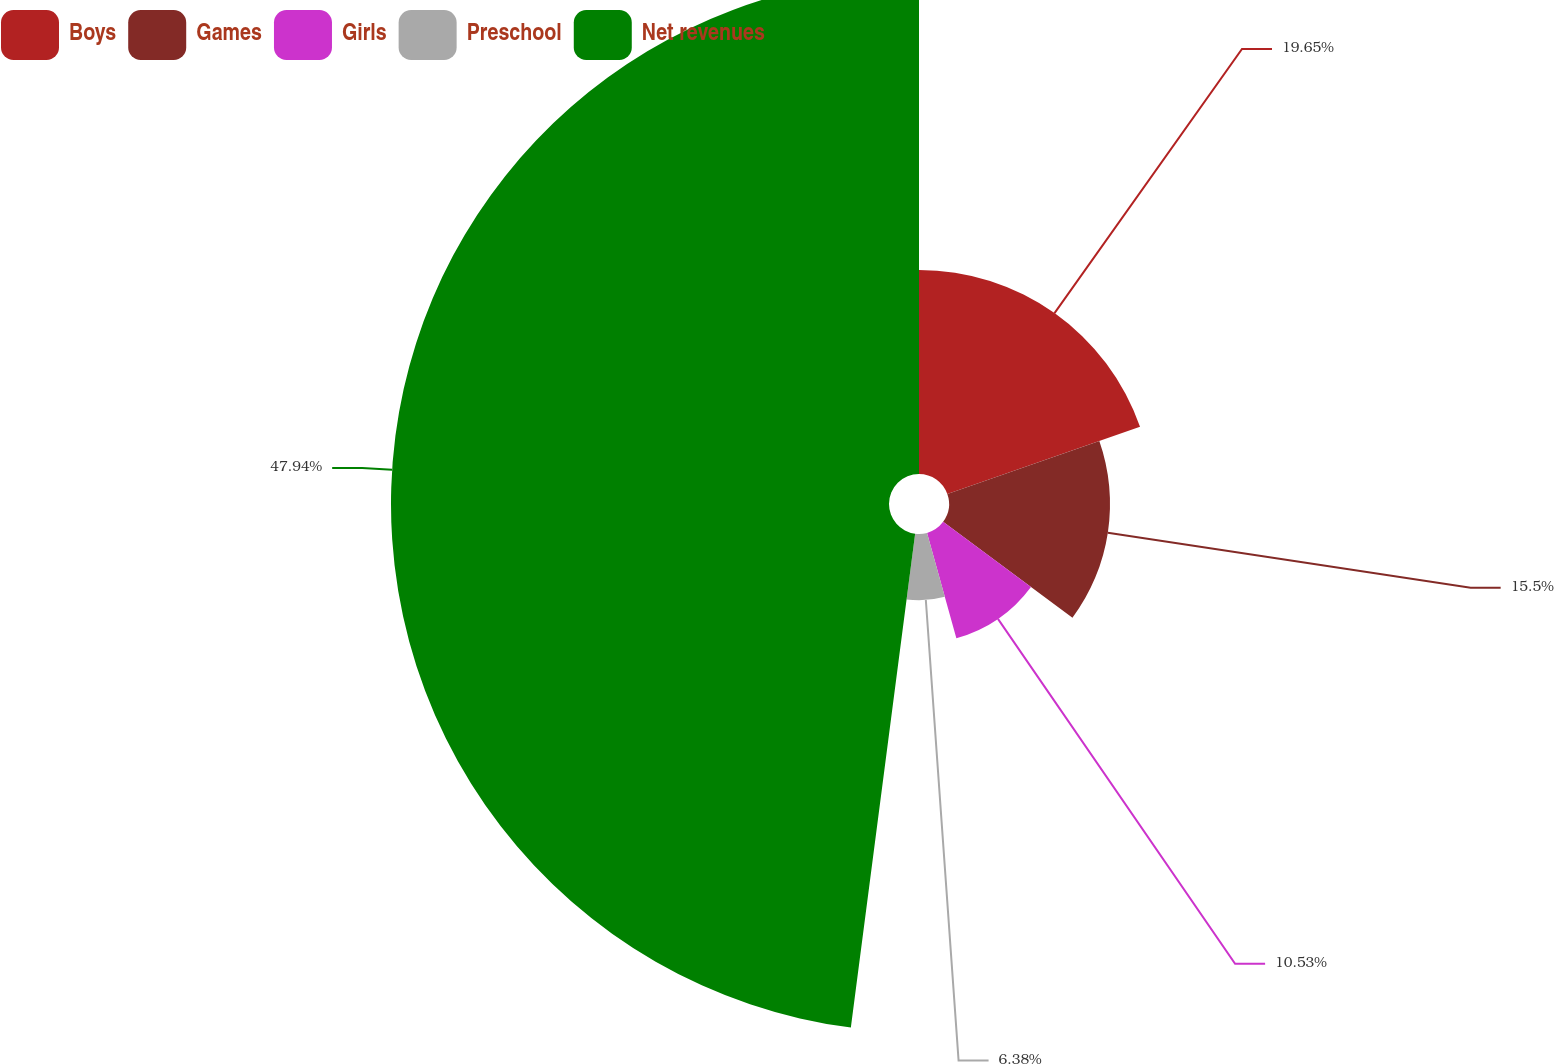Convert chart to OTSL. <chart><loc_0><loc_0><loc_500><loc_500><pie_chart><fcel>Boys<fcel>Games<fcel>Girls<fcel>Preschool<fcel>Net revenues<nl><fcel>19.65%<fcel>15.5%<fcel>10.53%<fcel>6.38%<fcel>47.94%<nl></chart> 